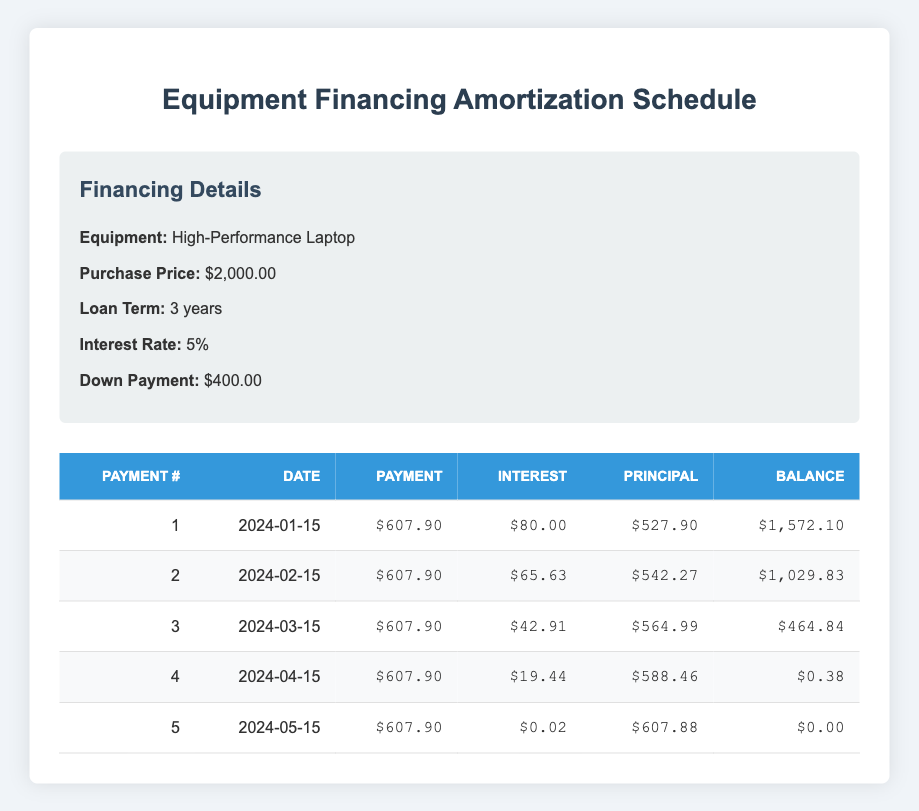What is the total amount financed after the down payment? The purchase price is $2000. The down payment is $400. To find the financed amount, subtract the down payment from the purchase price: $2000 - $400 = $1600.
Answer: 1600 How much is the payment per month? Each payment shown in the table is $607.90. Therefore, the payment per month is $607.90.
Answer: 607.90 On what date is the final payment due? The final payment is recorded as the 5th payment, which is due on 2024-05-15.
Answer: 2024-05-15 What is the total interest paid over the loan term? To find the total interest, sum the interest payments from all rows in the table: $80.00 + $65.63 + $42.91 + $19.44 + $0.02 = $207.00.
Answer: 207.00 Is the interest payment decreasing over time? Observing the interest payments from the table: $80.00, $65.63, $42.91, $19.44, $0.02 - all these values are decreasing. Therefore, yes, the interest payment is decreasing over time.
Answer: Yes What is the remaining balance after the second payment? After the second payment, the remaining balance shown in the table is $1,029.83, which is the value in that row's remaining balance column.
Answer: 1029.83 How much principal is paid off in the fourth payment? The principal payment for the fourth payment, as stated in the table, is $588.46.
Answer: 588.46 What is the average interest payment per month over the loan term? To calculate the average, sum the interest payments ($80.00 + $65.63 + $42.91 + $19.44 + $0.02 = $207.00) and divide by 5 (the number of payments): $207.00 / 5 = $41.40.
Answer: 41.40 What was the remaining balance before the last payment? The remaining balance before the last payment is found in the fourth payment row, which is $0.38.
Answer: 0.38 